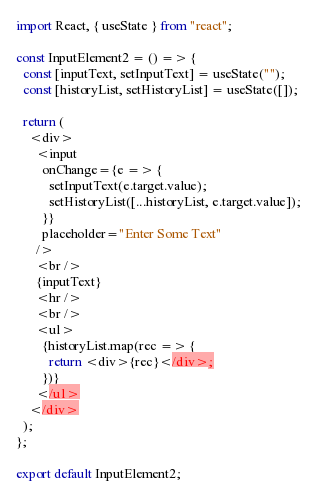Convert code to text. <code><loc_0><loc_0><loc_500><loc_500><_JavaScript_>import React, { useState } from "react";

const InputElement2 = () => {
  const [inputText, setInputText] = useState("");
  const [historyList, setHistoryList] = useState([]);

  return (
    <div>
      <input
        onChange={e => {
          setInputText(e.target.value);
          setHistoryList([...historyList, e.target.value]);
        }}
        placeholder="Enter Some Text"
      />
      <br />
      {inputText}
      <hr />
      <br />
      <ul>
        {historyList.map(rec => {
          return <div>{rec}</div>;
        })}
      </ul>
    </div>
  );
};

export default InputElement2;
</code> 